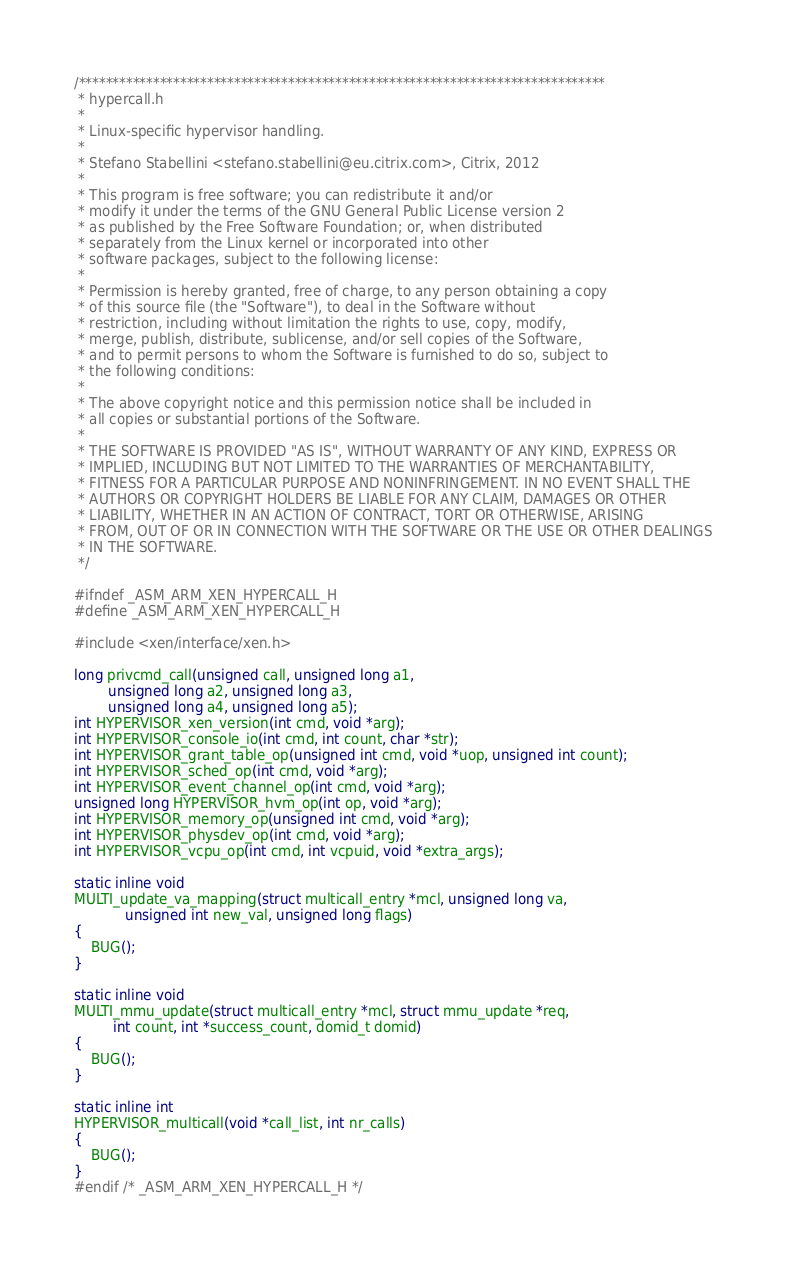<code> <loc_0><loc_0><loc_500><loc_500><_C_>/******************************************************************************
 * hypercall.h
 *
 * Linux-specific hypervisor handling.
 *
 * Stefano Stabellini <stefano.stabellini@eu.citrix.com>, Citrix, 2012
 *
 * This program is free software; you can redistribute it and/or
 * modify it under the terms of the GNU General Public License version 2
 * as published by the Free Software Foundation; or, when distributed
 * separately from the Linux kernel or incorporated into other
 * software packages, subject to the following license:
 *
 * Permission is hereby granted, free of charge, to any person obtaining a copy
 * of this source file (the "Software"), to deal in the Software without
 * restriction, including without limitation the rights to use, copy, modify,
 * merge, publish, distribute, sublicense, and/or sell copies of the Software,
 * and to permit persons to whom the Software is furnished to do so, subject to
 * the following conditions:
 *
 * The above copyright notice and this permission notice shall be included in
 * all copies or substantial portions of the Software.
 *
 * THE SOFTWARE IS PROVIDED "AS IS", WITHOUT WARRANTY OF ANY KIND, EXPRESS OR
 * IMPLIED, INCLUDING BUT NOT LIMITED TO THE WARRANTIES OF MERCHANTABILITY,
 * FITNESS FOR A PARTICULAR PURPOSE AND NONINFRINGEMENT. IN NO EVENT SHALL THE
 * AUTHORS OR COPYRIGHT HOLDERS BE LIABLE FOR ANY CLAIM, DAMAGES OR OTHER
 * LIABILITY, WHETHER IN AN ACTION OF CONTRACT, TORT OR OTHERWISE, ARISING
 * FROM, OUT OF OR IN CONNECTION WITH THE SOFTWARE OR THE USE OR OTHER DEALINGS
 * IN THE SOFTWARE.
 */

#ifndef _ASM_ARM_XEN_HYPERCALL_H
#define _ASM_ARM_XEN_HYPERCALL_H

#include <xen/interface/xen.h>

long privcmd_call(unsigned call, unsigned long a1,
		unsigned long a2, unsigned long a3,
		unsigned long a4, unsigned long a5);
int HYPERVISOR_xen_version(int cmd, void *arg);
int HYPERVISOR_console_io(int cmd, int count, char *str);
int HYPERVISOR_grant_table_op(unsigned int cmd, void *uop, unsigned int count);
int HYPERVISOR_sched_op(int cmd, void *arg);
int HYPERVISOR_event_channel_op(int cmd, void *arg);
unsigned long HYPERVISOR_hvm_op(int op, void *arg);
int HYPERVISOR_memory_op(unsigned int cmd, void *arg);
int HYPERVISOR_physdev_op(int cmd, void *arg);
int HYPERVISOR_vcpu_op(int cmd, int vcpuid, void *extra_args);

static inline void
MULTI_update_va_mapping(struct multicall_entry *mcl, unsigned long va,
			unsigned int new_val, unsigned long flags)
{
	BUG();
}

static inline void
MULTI_mmu_update(struct multicall_entry *mcl, struct mmu_update *req,
		 int count, int *success_count, domid_t domid)
{
	BUG();
}

static inline int
HYPERVISOR_multicall(void *call_list, int nr_calls)
{
	BUG();
}
#endif /* _ASM_ARM_XEN_HYPERCALL_H */
</code> 